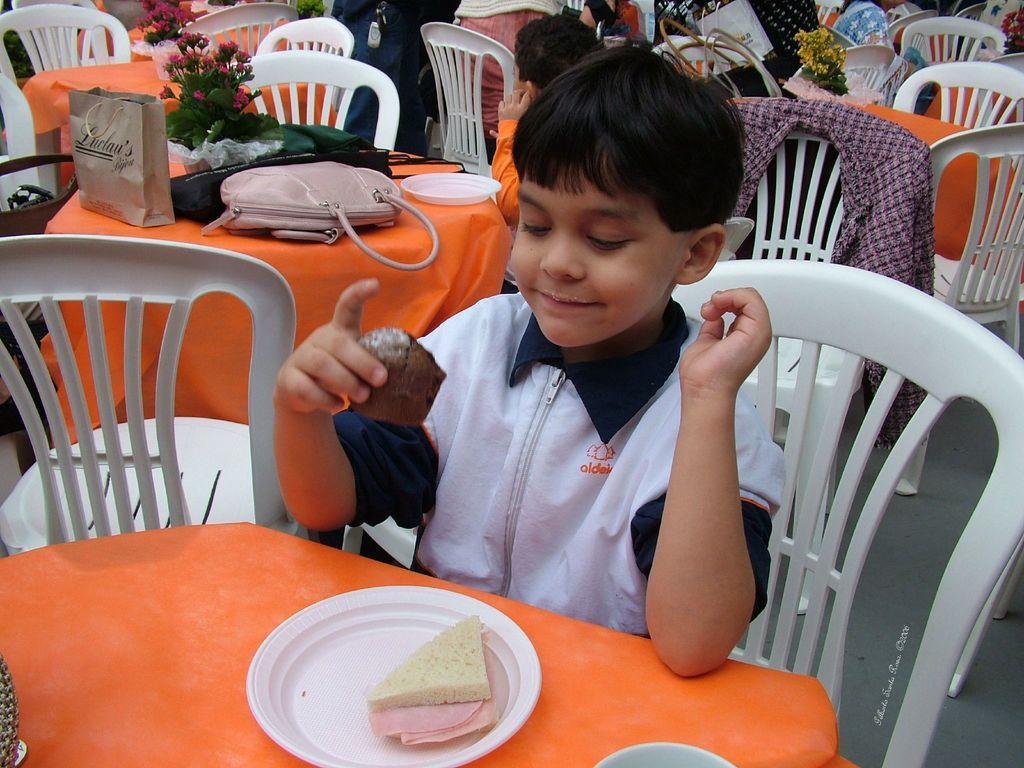How would you summarize this image in a sentence or two? The kid is sitting in a chair and holding a cake in his hand an there is a table in front of him which has a cake in a plate on it and there are group of people sitting in the background. 